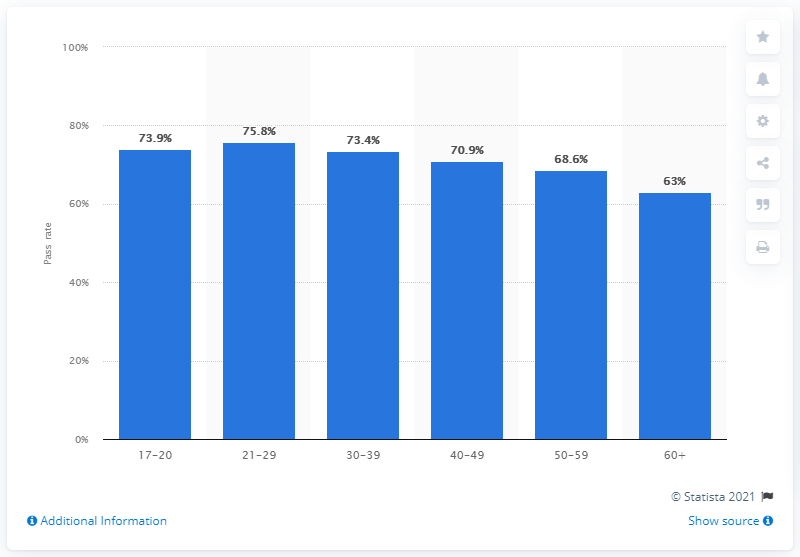List a handful of essential elements in this visual. According to the data, the pass rate for individuals aged 21 to 29 between April 2020 and March 2021 was 75.8%. 